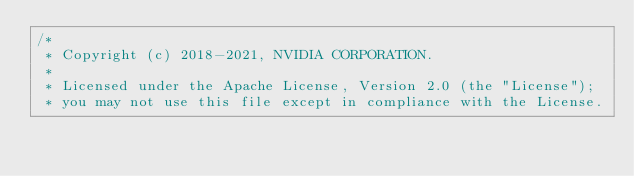Convert code to text. <code><loc_0><loc_0><loc_500><loc_500><_Cuda_>/*
 * Copyright (c) 2018-2021, NVIDIA CORPORATION.
 *
 * Licensed under the Apache License, Version 2.0 (the "License");
 * you may not use this file except in compliance with the License.</code> 